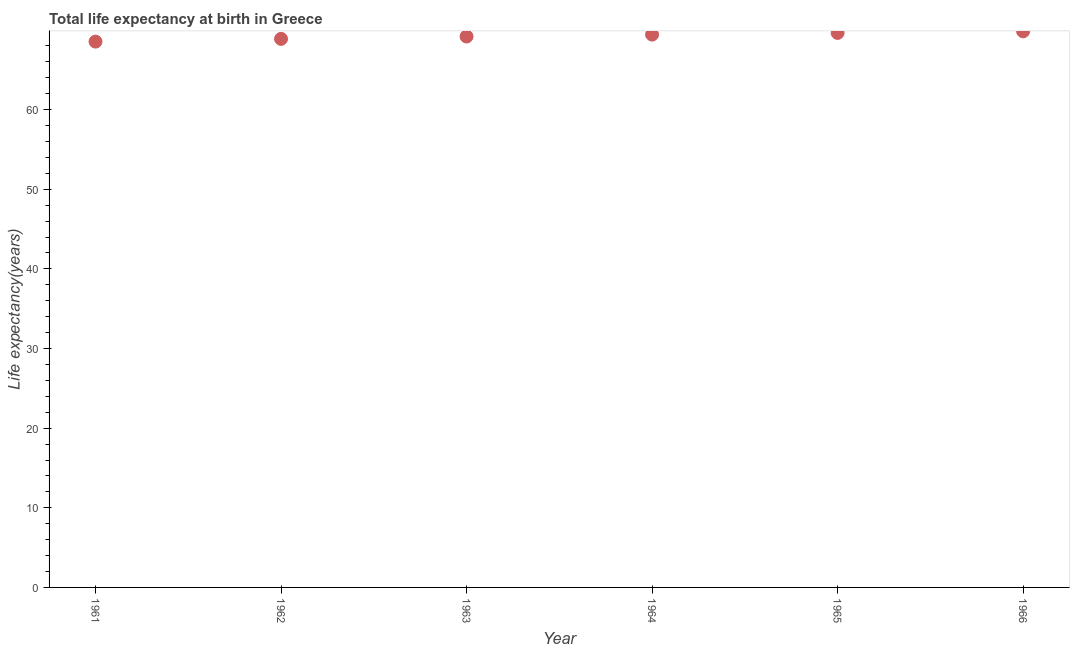What is the life expectancy at birth in 1964?
Give a very brief answer. 69.43. Across all years, what is the maximum life expectancy at birth?
Offer a terse response. 69.84. Across all years, what is the minimum life expectancy at birth?
Give a very brief answer. 68.55. In which year was the life expectancy at birth maximum?
Make the answer very short. 1966. In which year was the life expectancy at birth minimum?
Your response must be concise. 1961. What is the sum of the life expectancy at birth?
Your response must be concise. 415.53. What is the difference between the life expectancy at birth in 1961 and 1964?
Provide a succinct answer. -0.88. What is the average life expectancy at birth per year?
Ensure brevity in your answer.  69.26. What is the median life expectancy at birth?
Make the answer very short. 69.31. Do a majority of the years between 1961 and 1963 (inclusive) have life expectancy at birth greater than 50 years?
Your response must be concise. Yes. What is the ratio of the life expectancy at birth in 1962 to that in 1963?
Provide a short and direct response. 1. What is the difference between the highest and the second highest life expectancy at birth?
Ensure brevity in your answer.  0.2. Is the sum of the life expectancy at birth in 1961 and 1964 greater than the maximum life expectancy at birth across all years?
Provide a short and direct response. Yes. What is the difference between the highest and the lowest life expectancy at birth?
Offer a terse response. 1.29. How many dotlines are there?
Ensure brevity in your answer.  1. How many years are there in the graph?
Offer a terse response. 6. What is the difference between two consecutive major ticks on the Y-axis?
Your answer should be compact. 10. Does the graph contain any zero values?
Ensure brevity in your answer.  No. What is the title of the graph?
Your answer should be compact. Total life expectancy at birth in Greece. What is the label or title of the X-axis?
Provide a short and direct response. Year. What is the label or title of the Y-axis?
Your response must be concise. Life expectancy(years). What is the Life expectancy(years) in 1961?
Provide a succinct answer. 68.55. What is the Life expectancy(years) in 1962?
Your answer should be very brief. 68.89. What is the Life expectancy(years) in 1963?
Ensure brevity in your answer.  69.19. What is the Life expectancy(years) in 1964?
Offer a very short reply. 69.43. What is the Life expectancy(years) in 1965?
Give a very brief answer. 69.64. What is the Life expectancy(years) in 1966?
Ensure brevity in your answer.  69.84. What is the difference between the Life expectancy(years) in 1961 and 1962?
Provide a succinct answer. -0.34. What is the difference between the Life expectancy(years) in 1961 and 1963?
Ensure brevity in your answer.  -0.64. What is the difference between the Life expectancy(years) in 1961 and 1964?
Your answer should be very brief. -0.88. What is the difference between the Life expectancy(years) in 1961 and 1965?
Provide a succinct answer. -1.09. What is the difference between the Life expectancy(years) in 1961 and 1966?
Make the answer very short. -1.29. What is the difference between the Life expectancy(years) in 1962 and 1963?
Ensure brevity in your answer.  -0.29. What is the difference between the Life expectancy(years) in 1962 and 1964?
Provide a short and direct response. -0.54. What is the difference between the Life expectancy(years) in 1962 and 1965?
Your answer should be compact. -0.75. What is the difference between the Life expectancy(years) in 1962 and 1966?
Keep it short and to the point. -0.95. What is the difference between the Life expectancy(years) in 1963 and 1964?
Give a very brief answer. -0.24. What is the difference between the Life expectancy(years) in 1963 and 1965?
Provide a succinct answer. -0.45. What is the difference between the Life expectancy(years) in 1963 and 1966?
Your answer should be compact. -0.65. What is the difference between the Life expectancy(years) in 1964 and 1965?
Make the answer very short. -0.21. What is the difference between the Life expectancy(years) in 1964 and 1966?
Ensure brevity in your answer.  -0.41. What is the difference between the Life expectancy(years) in 1965 and 1966?
Your answer should be compact. -0.2. What is the ratio of the Life expectancy(years) in 1961 to that in 1964?
Provide a succinct answer. 0.99. What is the ratio of the Life expectancy(years) in 1961 to that in 1966?
Make the answer very short. 0.98. What is the ratio of the Life expectancy(years) in 1962 to that in 1963?
Offer a terse response. 1. What is the ratio of the Life expectancy(years) in 1962 to that in 1964?
Keep it short and to the point. 0.99. What is the ratio of the Life expectancy(years) in 1962 to that in 1966?
Provide a short and direct response. 0.99. What is the ratio of the Life expectancy(years) in 1963 to that in 1964?
Make the answer very short. 1. What is the ratio of the Life expectancy(years) in 1963 to that in 1965?
Keep it short and to the point. 0.99. What is the ratio of the Life expectancy(years) in 1963 to that in 1966?
Provide a succinct answer. 0.99. 